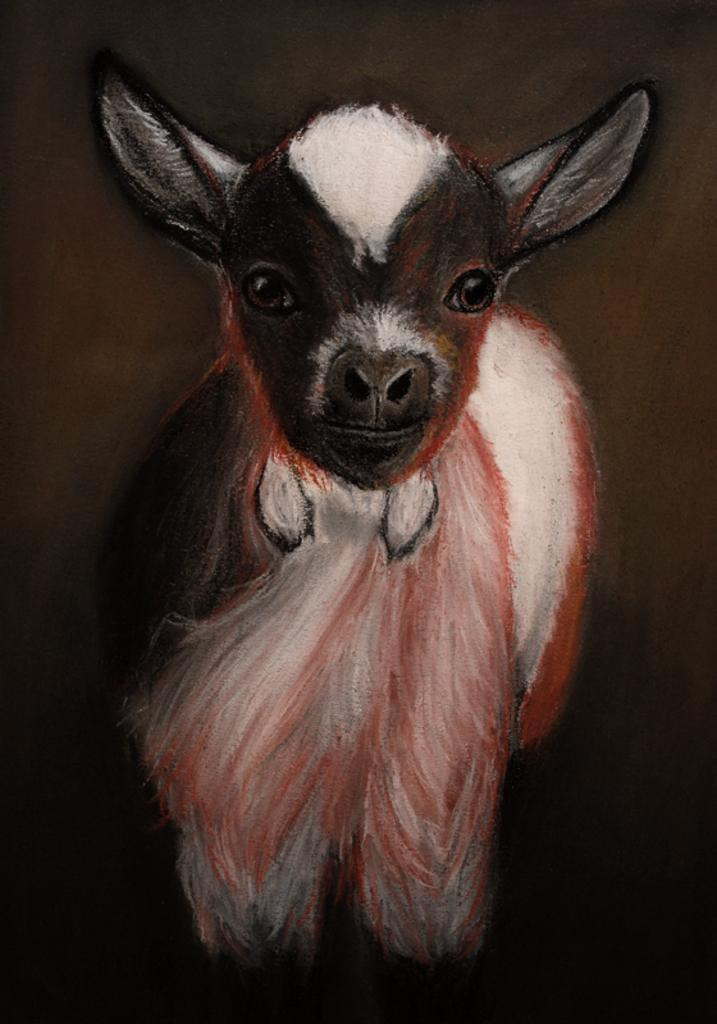What is depicted in the painting in the image? There is a painting of an animal in the image. Can you describe the overall color scheme of the image? The background of the image is dark. How many girls are visible in the image? There are no girls present in the image; it features a painting of an animal with a dark background. What part of the body is the chin located on in the image? There is no chin present in the image, as it features a painting of an animal with a dark background. 